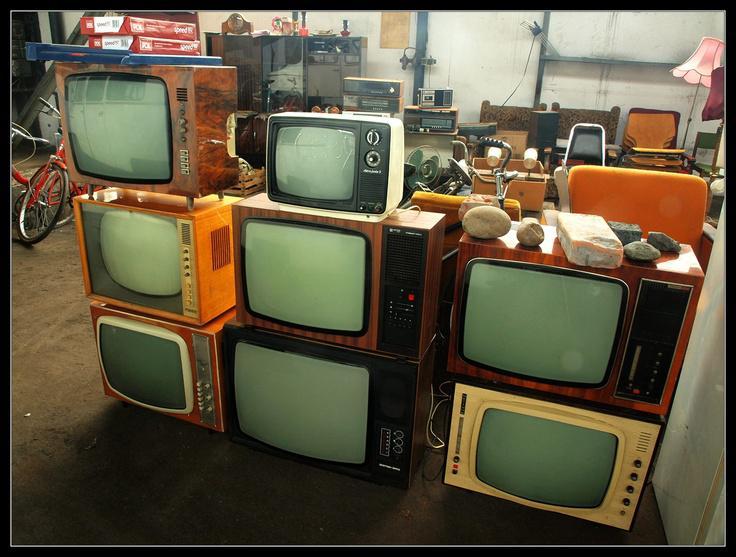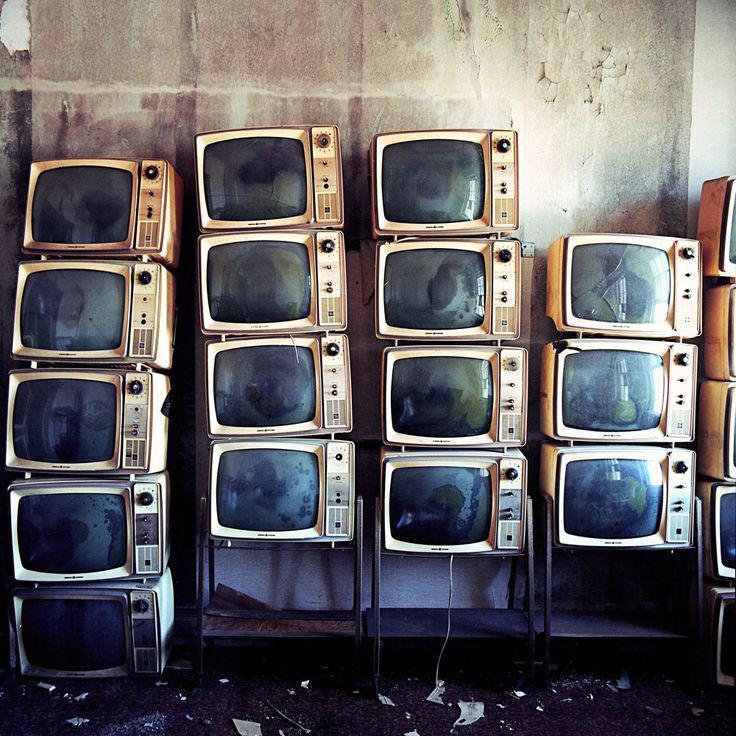The first image is the image on the left, the second image is the image on the right. Evaluate the accuracy of this statement regarding the images: "There are less than five television sets  in at least one of the images.". Is it true? Answer yes or no. No. The first image is the image on the left, the second image is the image on the right. Examine the images to the left and right. Is the description "Each image shows vertical stacks containing at least eight TV sets, and no image includes any part of a human." accurate? Answer yes or no. Yes. 